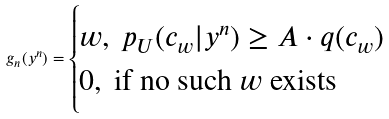Convert formula to latex. <formula><loc_0><loc_0><loc_500><loc_500>g _ { n } ( y ^ { n } ) = \begin{cases} w , \ p _ { U } ( c _ { w } | y ^ { n } ) \geq A \cdot q ( c _ { w } ) \\ 0 , \ \text {if no such $w$ exists} \end{cases}</formula> 